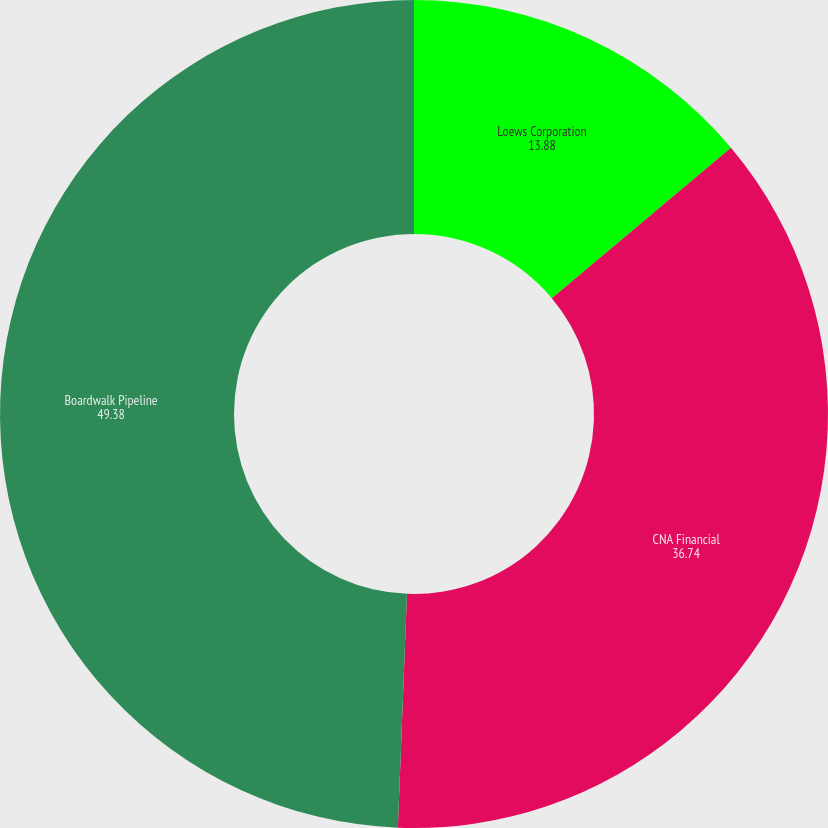<chart> <loc_0><loc_0><loc_500><loc_500><pie_chart><fcel>Loews Corporation<fcel>CNA Financial<fcel>Boardwalk Pipeline<nl><fcel>13.88%<fcel>36.74%<fcel>49.38%<nl></chart> 